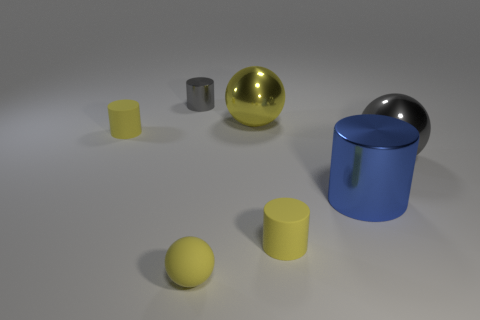There is a large object that is the same color as the small matte sphere; what material is it?
Make the answer very short. Metal. Is the tiny gray thing made of the same material as the small cylinder that is in front of the gray shiny ball?
Your response must be concise. No. How many metallic things are on the right side of the small gray metal thing and behind the large gray object?
Make the answer very short. 1. What shape is the yellow metal object that is the same size as the gray ball?
Give a very brief answer. Sphere. There is a yellow cylinder in front of the object on the left side of the small metallic object; is there a small cylinder that is behind it?
Provide a succinct answer. Yes. There is a tiny metal cylinder; is its color the same as the big shiny ball that is in front of the big yellow sphere?
Make the answer very short. Yes. How many other objects are the same color as the tiny metal object?
Offer a terse response. 1. There is a gray thing that is behind the large thing on the right side of the large metal cylinder; what is its size?
Make the answer very short. Small. What number of objects are tiny yellow cylinders behind the blue cylinder or yellow balls?
Give a very brief answer. 3. Are there any gray shiny cylinders that have the same size as the yellow metallic ball?
Give a very brief answer. No. 